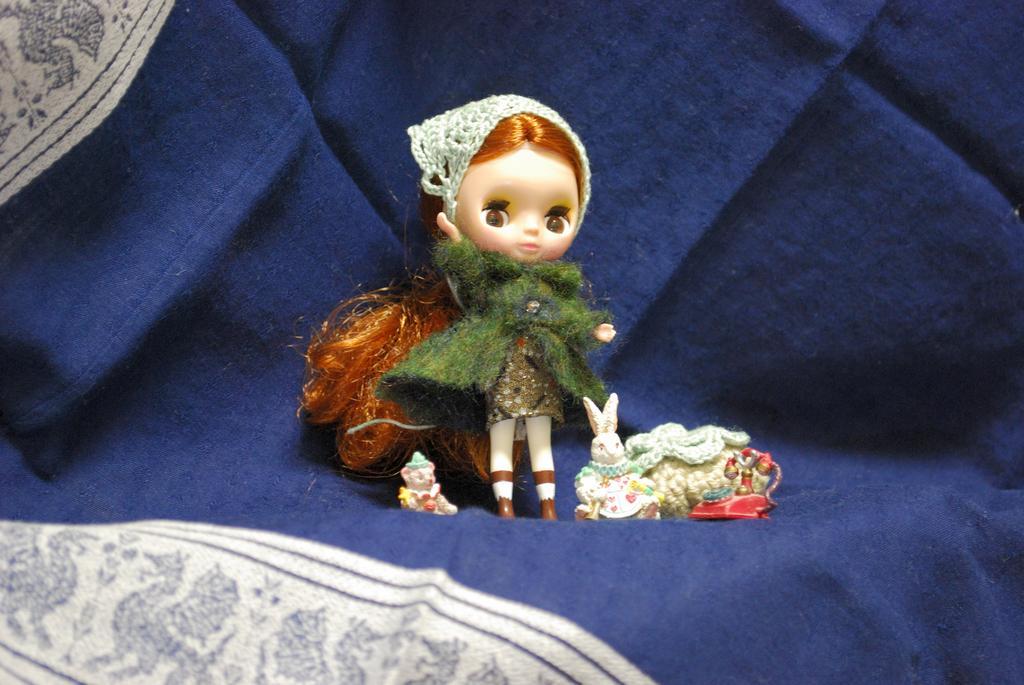Could you give a brief overview of what you see in this image? In this image we can see one blue cloth, on roll and some toys on the surface. 